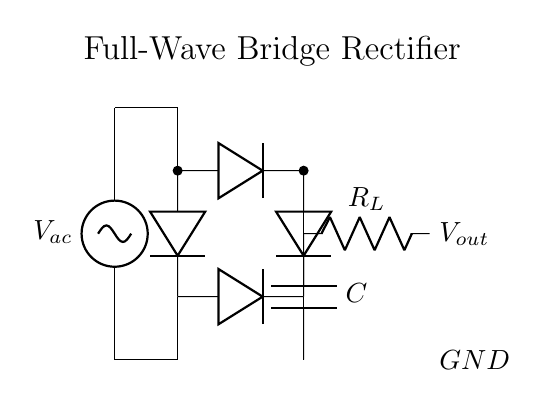What type of circuit is depicted? The circuit is a full-wave bridge rectifier, which is known for converting AC voltage into DC voltage using four diodes arranged in a bridge configuration.
Answer: full-wave bridge rectifier How many diodes are in this circuit? There are four diodes in the circuit, all of which are configured in a bridge formation to enable the full-wave rectification of the alternating current.
Answer: four What does the load resistor symbolize? The load resistor (labeled as R_L) represents the component that consumes power in the circuit, essentially converting the output DC voltage into useful work or heat.
Answer: R_L What is the purpose of the smoothing capacitor? The smoothing capacitor (labeled as C) serves to reduce the ripple in the output voltage, smoothing out fluctuations and providing a more stable DC voltage to the load.
Answer: C What is the polarity of the output voltage? The output voltage, labeled as V_out, has a positive terminal at the junction between the diodes and the load resistor, indicating that it is a positive DC voltage relative to ground.
Answer: positive What happens to the current during the negative half cycle of AC? During the negative half cycle of the AC source, two of the diodes conduct, allowing current to flow in the same direction through the load resistor, thus ensuring that the output remains unidirectional and positive.
Answer: unidirectional How can this circuit be improved for better performance? To improve performance, enhancements like adding a larger smoothing capacitor or using a faster switching diode may be implemented to reduce voltage fluctuations or handle higher frequencies more effectively.
Answer: larger capacitor, faster diodes 